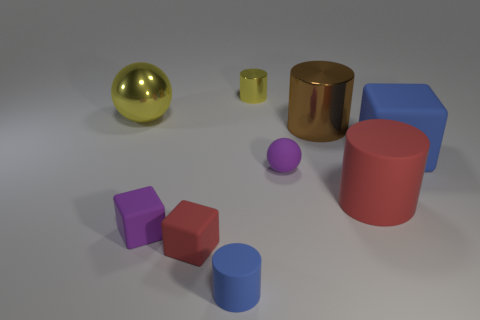The big cylinder on the left side of the large red cylinder is what color?
Your answer should be very brief. Brown. What is the material of the big yellow thing behind the red matte object on the left side of the brown shiny object?
Your response must be concise. Metal. Are there any purple rubber cubes that have the same size as the yellow shiny sphere?
Offer a terse response. No. How many things are metal cylinders that are behind the big brown object or tiny matte objects that are behind the tiny purple matte cube?
Offer a terse response. 2. Do the shiny object on the right side of the yellow cylinder and the sphere on the left side of the tiny blue matte object have the same size?
Give a very brief answer. Yes. Is there a cube that is on the right side of the tiny purple thing on the right side of the tiny blue cylinder?
Offer a very short reply. Yes. There is a blue rubber cylinder; how many large blue rubber objects are in front of it?
Make the answer very short. 0. What number of other objects are the same color as the big shiny sphere?
Your response must be concise. 1. Is the number of big objects in front of the small matte ball less than the number of yellow metallic cylinders that are in front of the small matte cylinder?
Make the answer very short. No. How many objects are either balls that are right of the yellow sphere or small blue rubber blocks?
Ensure brevity in your answer.  1. 